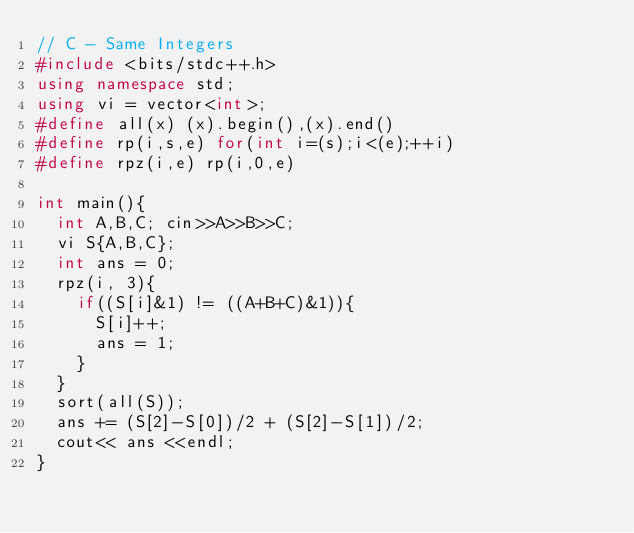<code> <loc_0><loc_0><loc_500><loc_500><_C++_>// C - Same Integers
#include <bits/stdc++.h>
using namespace std;
using vi = vector<int>;
#define all(x) (x).begin(),(x).end()
#define rp(i,s,e) for(int i=(s);i<(e);++i)
#define rpz(i,e) rp(i,0,e)

int main(){
	int A,B,C; cin>>A>>B>>C;
	vi S{A,B,C};
	int ans = 0;
	rpz(i, 3){
		if((S[i]&1) != ((A+B+C)&1)){
			S[i]++;
			ans = 1;
		}
	}
	sort(all(S));
	ans += (S[2]-S[0])/2 + (S[2]-S[1])/2;
	cout<< ans <<endl;
}</code> 